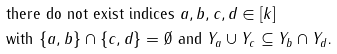<formula> <loc_0><loc_0><loc_500><loc_500>& \text {there do not exist indices $a,b,c,d\in[k]$} \\ & \text {with $\{a,b\}\cap\{c,d\}=\emptyset$ and $Y_{a}\cup Y_{c}\subseteq Y_{b}\cap Y_{d}$.}</formula> 